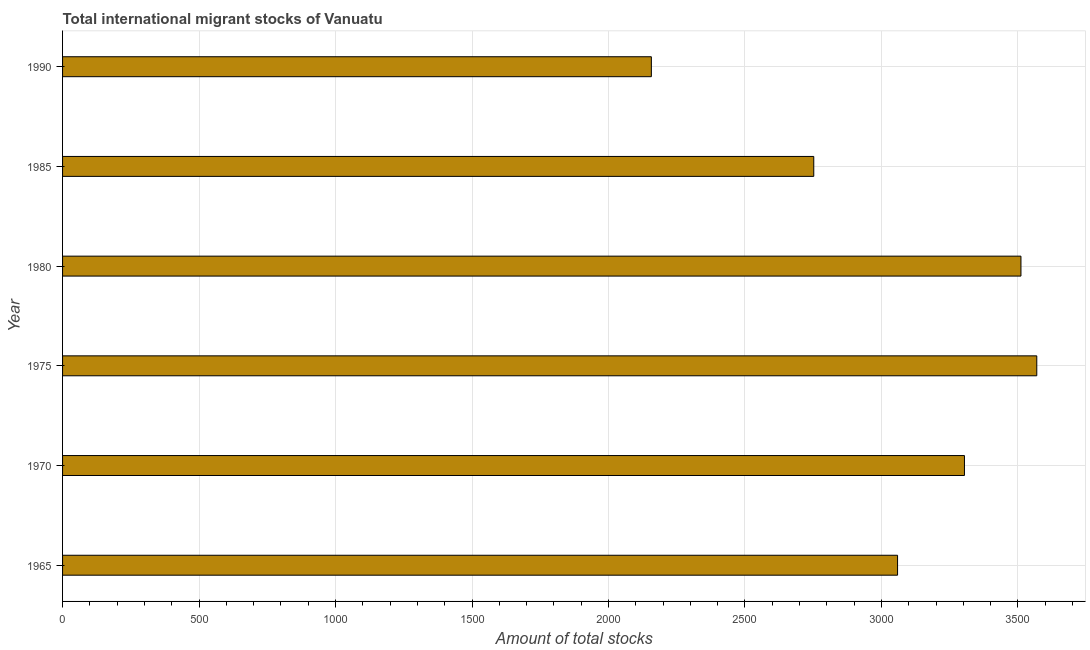Does the graph contain grids?
Your answer should be compact. Yes. What is the title of the graph?
Provide a succinct answer. Total international migrant stocks of Vanuatu. What is the label or title of the X-axis?
Your response must be concise. Amount of total stocks. What is the total number of international migrant stock in 1970?
Keep it short and to the point. 3304. Across all years, what is the maximum total number of international migrant stock?
Your response must be concise. 3569. Across all years, what is the minimum total number of international migrant stock?
Give a very brief answer. 2157. In which year was the total number of international migrant stock maximum?
Provide a succinct answer. 1975. In which year was the total number of international migrant stock minimum?
Provide a short and direct response. 1990. What is the sum of the total number of international migrant stock?
Your answer should be compact. 1.84e+04. What is the difference between the total number of international migrant stock in 1980 and 1990?
Provide a succinct answer. 1354. What is the average total number of international migrant stock per year?
Provide a succinct answer. 3058. What is the median total number of international migrant stock?
Give a very brief answer. 3181.5. Do a majority of the years between 1990 and 1985 (inclusive) have total number of international migrant stock greater than 800 ?
Offer a very short reply. No. What is the ratio of the total number of international migrant stock in 1980 to that in 1990?
Offer a very short reply. 1.63. Is the total number of international migrant stock in 1975 less than that in 1990?
Keep it short and to the point. No. Is the sum of the total number of international migrant stock in 1970 and 1990 greater than the maximum total number of international migrant stock across all years?
Make the answer very short. Yes. What is the difference between the highest and the lowest total number of international migrant stock?
Offer a very short reply. 1412. Are all the bars in the graph horizontal?
Your answer should be very brief. Yes. What is the Amount of total stocks in 1965?
Offer a very short reply. 3059. What is the Amount of total stocks of 1970?
Make the answer very short. 3304. What is the Amount of total stocks in 1975?
Make the answer very short. 3569. What is the Amount of total stocks of 1980?
Your answer should be very brief. 3511. What is the Amount of total stocks in 1985?
Provide a succinct answer. 2752. What is the Amount of total stocks of 1990?
Your response must be concise. 2157. What is the difference between the Amount of total stocks in 1965 and 1970?
Give a very brief answer. -245. What is the difference between the Amount of total stocks in 1965 and 1975?
Your answer should be compact. -510. What is the difference between the Amount of total stocks in 1965 and 1980?
Provide a succinct answer. -452. What is the difference between the Amount of total stocks in 1965 and 1985?
Your answer should be very brief. 307. What is the difference between the Amount of total stocks in 1965 and 1990?
Your answer should be very brief. 902. What is the difference between the Amount of total stocks in 1970 and 1975?
Your answer should be compact. -265. What is the difference between the Amount of total stocks in 1970 and 1980?
Offer a terse response. -207. What is the difference between the Amount of total stocks in 1970 and 1985?
Your answer should be compact. 552. What is the difference between the Amount of total stocks in 1970 and 1990?
Your answer should be compact. 1147. What is the difference between the Amount of total stocks in 1975 and 1985?
Offer a terse response. 817. What is the difference between the Amount of total stocks in 1975 and 1990?
Offer a very short reply. 1412. What is the difference between the Amount of total stocks in 1980 and 1985?
Your answer should be very brief. 759. What is the difference between the Amount of total stocks in 1980 and 1990?
Offer a terse response. 1354. What is the difference between the Amount of total stocks in 1985 and 1990?
Offer a very short reply. 595. What is the ratio of the Amount of total stocks in 1965 to that in 1970?
Your response must be concise. 0.93. What is the ratio of the Amount of total stocks in 1965 to that in 1975?
Offer a very short reply. 0.86. What is the ratio of the Amount of total stocks in 1965 to that in 1980?
Ensure brevity in your answer.  0.87. What is the ratio of the Amount of total stocks in 1965 to that in 1985?
Offer a terse response. 1.11. What is the ratio of the Amount of total stocks in 1965 to that in 1990?
Make the answer very short. 1.42. What is the ratio of the Amount of total stocks in 1970 to that in 1975?
Keep it short and to the point. 0.93. What is the ratio of the Amount of total stocks in 1970 to that in 1980?
Your answer should be compact. 0.94. What is the ratio of the Amount of total stocks in 1970 to that in 1985?
Provide a short and direct response. 1.2. What is the ratio of the Amount of total stocks in 1970 to that in 1990?
Offer a terse response. 1.53. What is the ratio of the Amount of total stocks in 1975 to that in 1980?
Ensure brevity in your answer.  1.02. What is the ratio of the Amount of total stocks in 1975 to that in 1985?
Your response must be concise. 1.3. What is the ratio of the Amount of total stocks in 1975 to that in 1990?
Provide a succinct answer. 1.66. What is the ratio of the Amount of total stocks in 1980 to that in 1985?
Ensure brevity in your answer.  1.28. What is the ratio of the Amount of total stocks in 1980 to that in 1990?
Keep it short and to the point. 1.63. What is the ratio of the Amount of total stocks in 1985 to that in 1990?
Give a very brief answer. 1.28. 